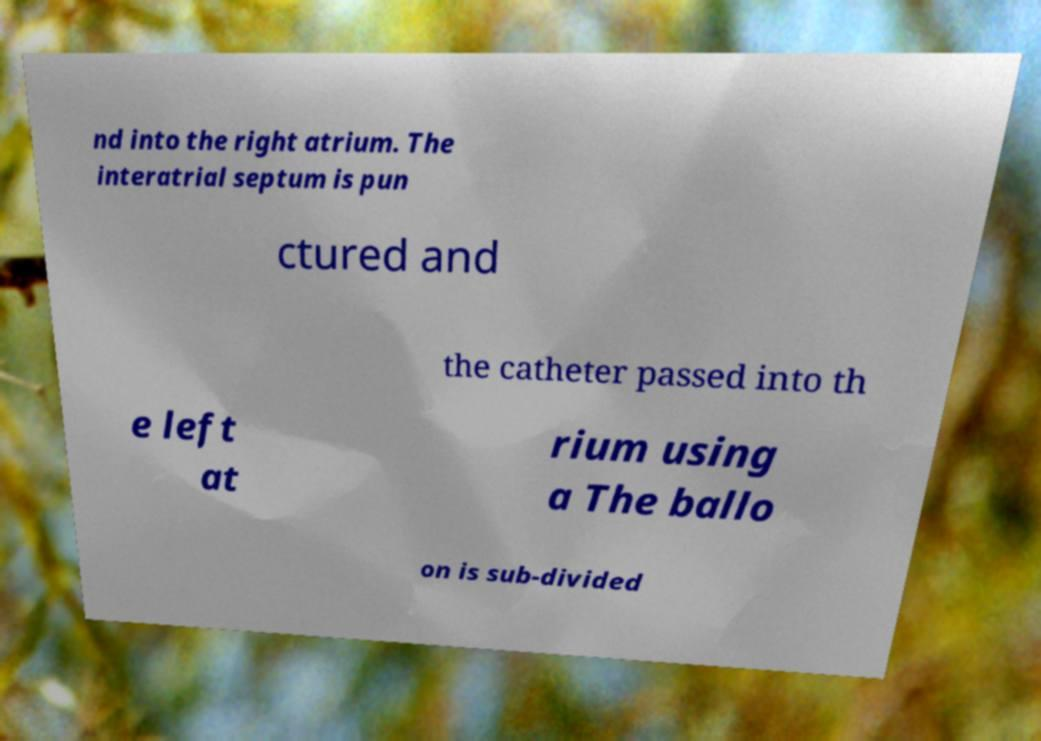Please read and relay the text visible in this image. What does it say? nd into the right atrium. The interatrial septum is pun ctured and the catheter passed into th e left at rium using a The ballo on is sub-divided 